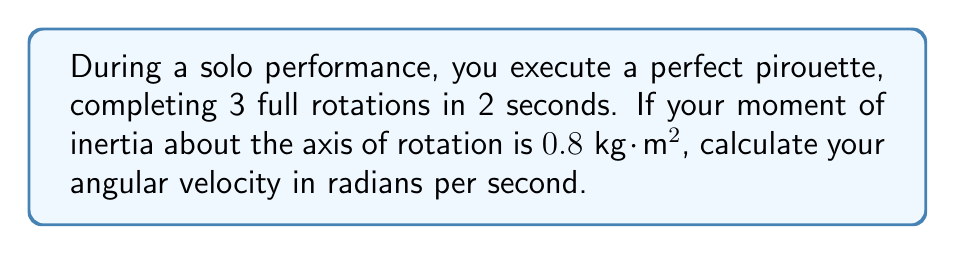Teach me how to tackle this problem. To solve this problem, we'll follow these steps:

1) First, let's define angular velocity ($\omega$):
   Angular velocity is the rate of change of angular position with respect to time.

2) We know that one full rotation equals $2\pi$ radians. So, 3 rotations equal:
   $$\theta = 3 \cdot 2\pi = 6\pi \text{ radians}$$

3) The angular velocity is given by:
   $$\omega = \frac{\Delta \theta}{\Delta t}$$
   where $\Delta \theta$ is the change in angular position and $\Delta t$ is the time taken.

4) Substituting our values:
   $$\omega = \frac{6\pi \text{ radians}}{2 \text{ seconds}}$$

5) Simplify:
   $$\omega = 3\pi \text{ radians/second}$$

Note: The moment of inertia given in the problem ($0.8 \text{ kg}\cdot\text{m}^2$) is not needed to calculate the angular velocity. It would be used if we needed to calculate torque or angular momentum.
Answer: $3\pi \text{ rad/s}$ 